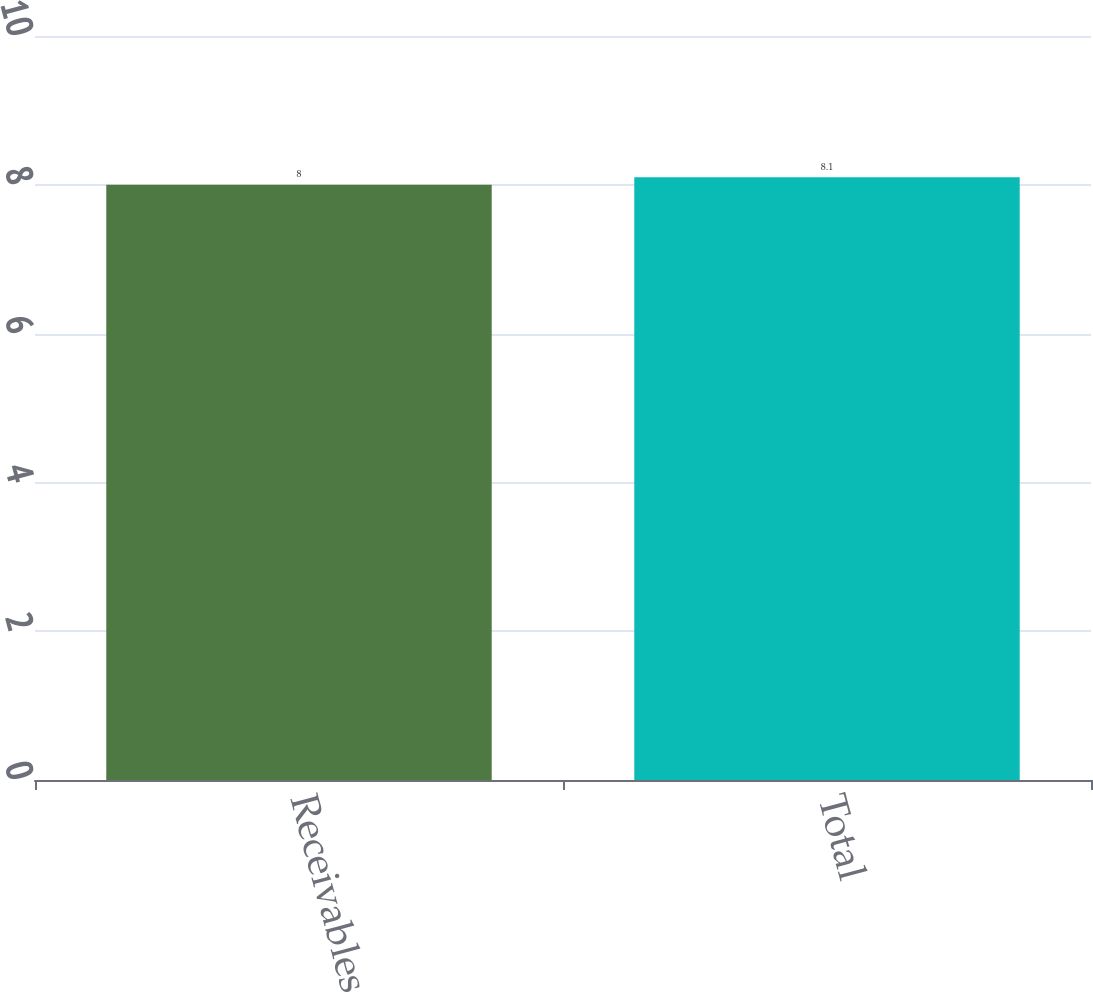Convert chart to OTSL. <chart><loc_0><loc_0><loc_500><loc_500><bar_chart><fcel>Receivables<fcel>Total<nl><fcel>8<fcel>8.1<nl></chart> 